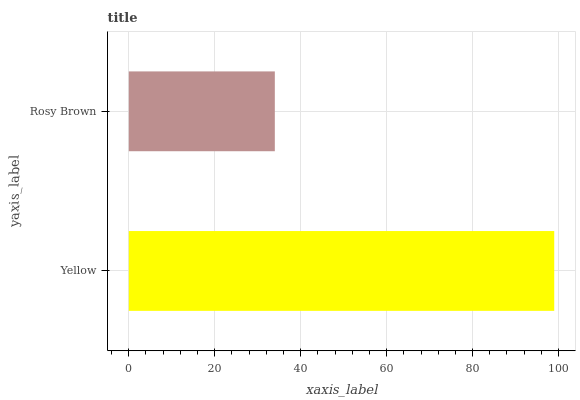Is Rosy Brown the minimum?
Answer yes or no. Yes. Is Yellow the maximum?
Answer yes or no. Yes. Is Rosy Brown the maximum?
Answer yes or no. No. Is Yellow greater than Rosy Brown?
Answer yes or no. Yes. Is Rosy Brown less than Yellow?
Answer yes or no. Yes. Is Rosy Brown greater than Yellow?
Answer yes or no. No. Is Yellow less than Rosy Brown?
Answer yes or no. No. Is Yellow the high median?
Answer yes or no. Yes. Is Rosy Brown the low median?
Answer yes or no. Yes. Is Rosy Brown the high median?
Answer yes or no. No. Is Yellow the low median?
Answer yes or no. No. 